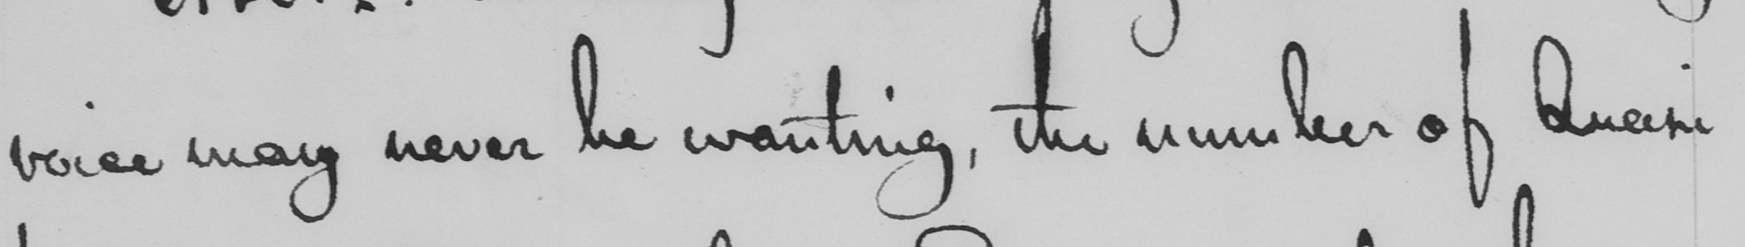Please transcribe the handwritten text in this image. voice may never be wanting , the number of Quasi 